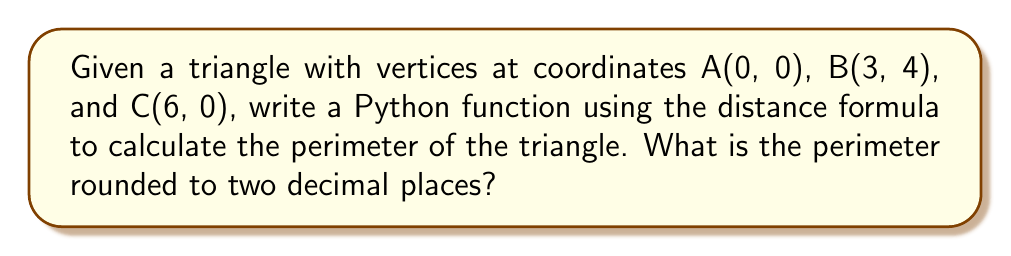Help me with this question. To solve this problem, we'll follow these steps:

1. Write a Python function to calculate the distance between two points using the distance formula:
   $$d = \sqrt{(x_2 - x_1)^2 + (y_2 - y_1)^2}$$

2. Calculate the lengths of the three sides of the triangle using the distance function.

3. Sum the lengths of the sides to get the perimeter.

4. Round the result to two decimal places.

Here's the Python code to implement this solution:

```python
import math

def distance(x1, y1, x2, y2):
    return math.sqrt((x2 - x1)**2 + (y2 - y1)**2)

def triangle_perimeter(ax, ay, bx, by, cx, cy):
    side_ab = distance(ax, ay, bx, by)
    side_bc = distance(bx, by, cx, cy)
    side_ca = distance(cx, cy, ax, ay)
    return round(side_ab + side_bc + side_ca, 2)

perimeter = triangle_perimeter(0, 0, 3, 4, 6, 0)
print(f"The perimeter of the triangle is {perimeter}")
```

Let's calculate each side length:

Side AB: $$\sqrt{(3 - 0)^2 + (4 - 0)^2} = \sqrt{9 + 16} = \sqrt{25} = 5$$

Side BC: $$\sqrt{(6 - 3)^2 + (0 - 4)^2} = \sqrt{9 + 16} = \sqrt{25} = 5$$

Side CA: $$\sqrt{(0 - 6)^2 + (0 - 0)^2} = \sqrt{36 + 0} = \sqrt{36} = 6$$

The perimeter is the sum of these sides: $5 + 5 + 6 = 16$

Rounding to two decimal places gives us 16.00.
Answer: 16.00 